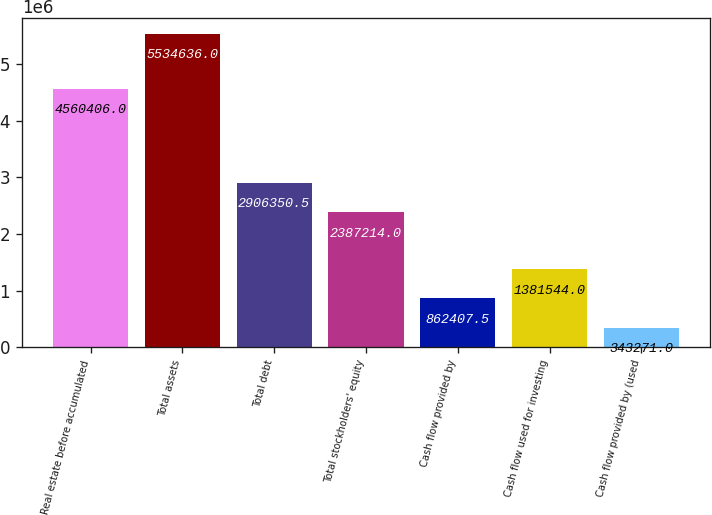Convert chart to OTSL. <chart><loc_0><loc_0><loc_500><loc_500><bar_chart><fcel>Real estate before accumulated<fcel>Total assets<fcel>Total debt<fcel>Total stockholders' equity<fcel>Cash flow provided by<fcel>Cash flow used for investing<fcel>Cash flow provided by (used<nl><fcel>4.56041e+06<fcel>5.53464e+06<fcel>2.90635e+06<fcel>2.38721e+06<fcel>862408<fcel>1.38154e+06<fcel>343271<nl></chart> 